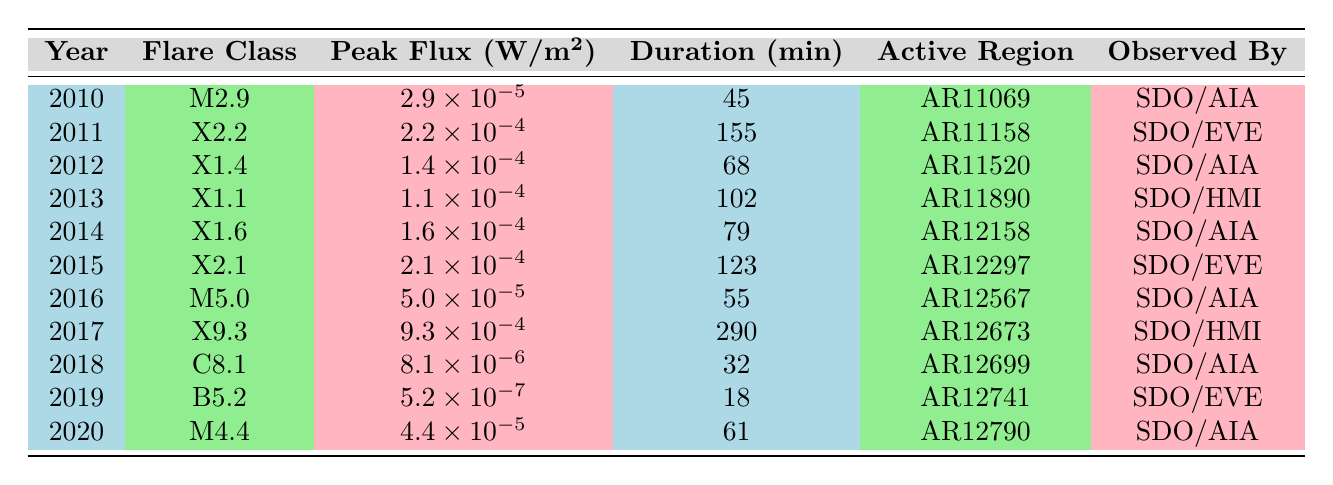What was the flare class of the largest solar flare observed in the data? The largest solar flare is determined by the peak flux value, which is highest for the flare class X9.3 in 2017.
Answer: X9.3 In which year was the shortest duration solar flare observed? To find the shortest duration flare, we check the duration column, where the flare class B5.2 in 2019 has the shortest duration of 18 minutes.
Answer: 2019 How many solar flares were classified as X-class during the period from 2010 to 2020? We count the occurrences of flare classes that start with X: X2.2 in 2011, X1.4 in 2012, X1.1 in 2013, X1.6 in 2014, X2.1 in 2015, X9.3 in 2017. This totals six X-class flares.
Answer: 6 What is the average peak flux of all the solar flares recorded? We sum the peak flux values: 2.9e-5 + 2.2e-4 + 1.4e-4 + 1.1e-4 + 1.6e-4 + 2.1e-4 + 5.0e-5 + 9.3e-4 + 8.1e-6 + 5.2e-7 + 4.4e-5 = total flux. Then divide the total by 11 (the number of flares) to find the average. The average works out to approximately 1.4e-4.
Answer: 1.4e-4 Did any solar flares have a peak flux greater than 1e-4 W/m²? By looking at the peak flux values, we see that the following flares exceed this value: X2.2, X1.4, X1.1, X1.6, X2.1, X9.3. Therefore, yes, at least six flares have a peak flux greater than 1e-4.
Answer: Yes Which active region reported the longest-lasting solar flare? The longest duration is associated with the flare class X9.3 in 2017, which lasted for 290 minutes, pointing to active region AR12673.
Answer: AR12673 Was there a solar flare observed by SDO/HMI in 2010? The table shows that no entries for the year 2010 list SDO/HMI as the observing entity, meaning the answer is no.
Answer: No What was the peak flux difference between the highest and lowest solar flare in the dataset? The highest peak flux was for the X9.3 flare (9.3e-4 W/m²) and the lowest for B5.2 (5.2e-7 W/m²). The difference is calculated as 9.3e-4 - 5.2e-7 = approximately 9.2e-4 W/m².
Answer: 9.2e-4 How many flares were observed by SDO/AIA in 2014 and after? In 2014, there is one (X1.6), in 2015 (X2.1), in 2016 (M5.0), in 2017 (none), in 2018 (C8.1), in 2019 (none), and in 2020 (M4.4). This means there are four observed by SDO/AIA from 2014 onward.
Answer: 4 